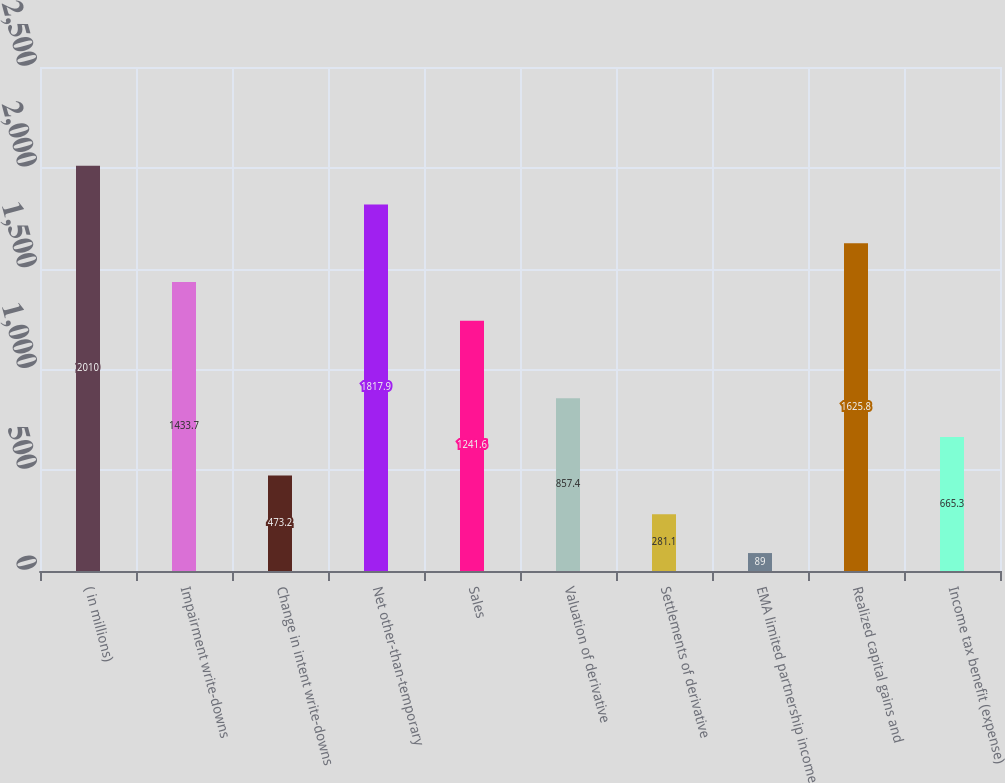Convert chart. <chart><loc_0><loc_0><loc_500><loc_500><bar_chart><fcel>( in millions)<fcel>Impairment write-downs<fcel>Change in intent write-downs<fcel>Net other-than-temporary<fcel>Sales<fcel>Valuation of derivative<fcel>Settlements of derivative<fcel>EMA limited partnership income<fcel>Realized capital gains and<fcel>Income tax benefit (expense)<nl><fcel>2010<fcel>1433.7<fcel>473.2<fcel>1817.9<fcel>1241.6<fcel>857.4<fcel>281.1<fcel>89<fcel>1625.8<fcel>665.3<nl></chart> 